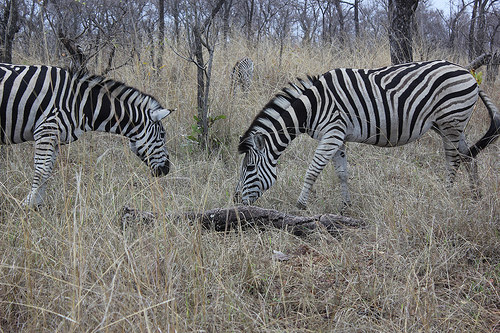Do you see zebras in the grass?
Answer the question using a single word or phrase. Yes 